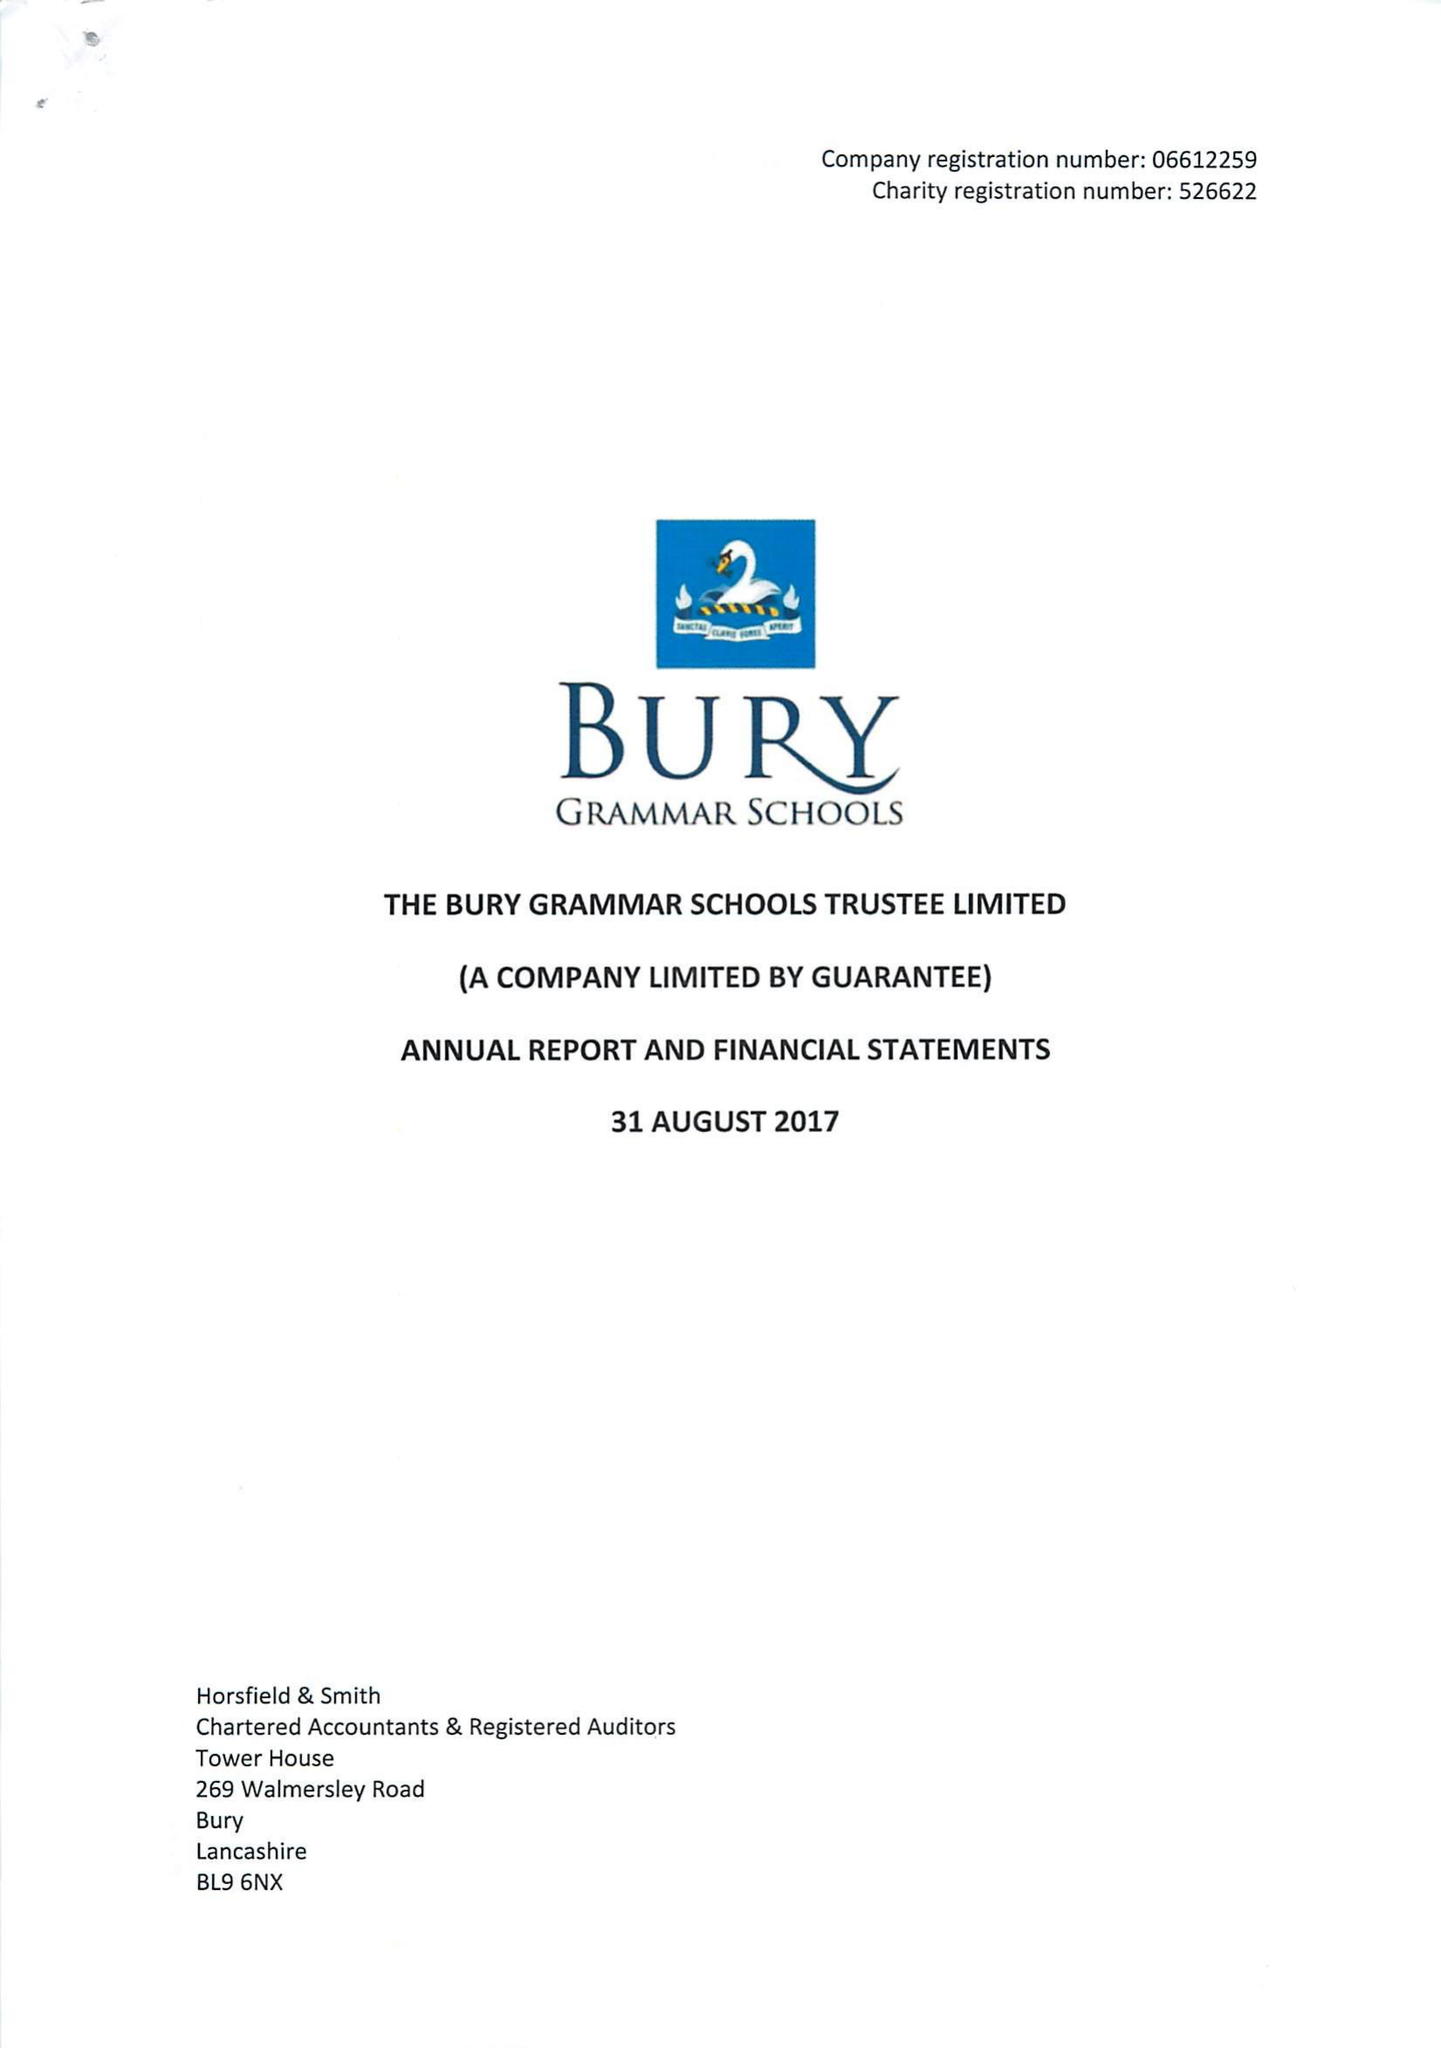What is the value for the report_date?
Answer the question using a single word or phrase. 2017-08-31 